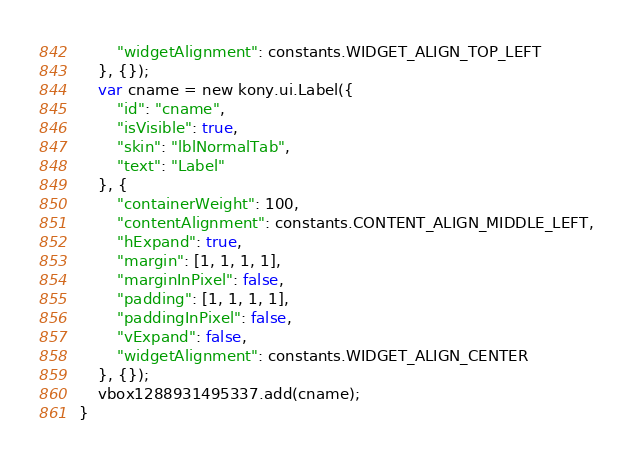<code> <loc_0><loc_0><loc_500><loc_500><_JavaScript_>        "widgetAlignment": constants.WIDGET_ALIGN_TOP_LEFT
    }, {});
    var cname = new kony.ui.Label({
        "id": "cname",
        "isVisible": true,
        "skin": "lblNormalTab",
        "text": "Label"
    }, {
        "containerWeight": 100,
        "contentAlignment": constants.CONTENT_ALIGN_MIDDLE_LEFT,
        "hExpand": true,
        "margin": [1, 1, 1, 1],
        "marginInPixel": false,
        "padding": [1, 1, 1, 1],
        "paddingInPixel": false,
        "vExpand": false,
        "widgetAlignment": constants.WIDGET_ALIGN_CENTER
    }, {});
    vbox1288931495337.add(cname);
}</code> 